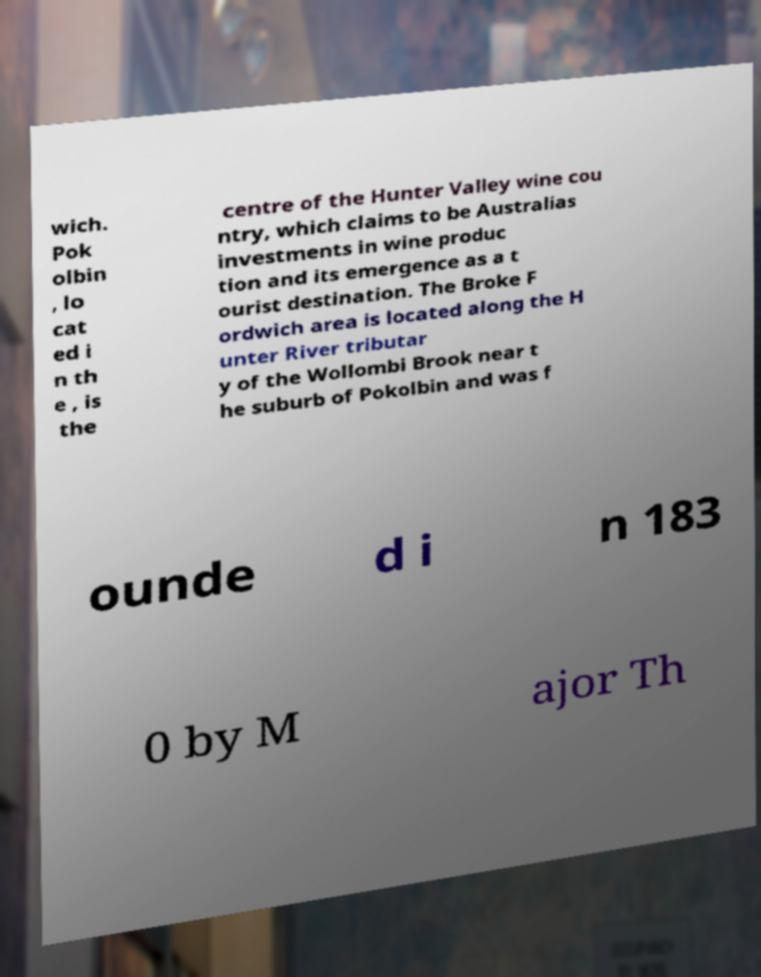Could you assist in decoding the text presented in this image and type it out clearly? wich. Pok olbin , lo cat ed i n th e , is the centre of the Hunter Valley wine cou ntry, which claims to be Australias investments in wine produc tion and its emergence as a t ourist destination. The Broke F ordwich area is located along the H unter River tributar y of the Wollombi Brook near t he suburb of Pokolbin and was f ounde d i n 183 0 by M ajor Th 